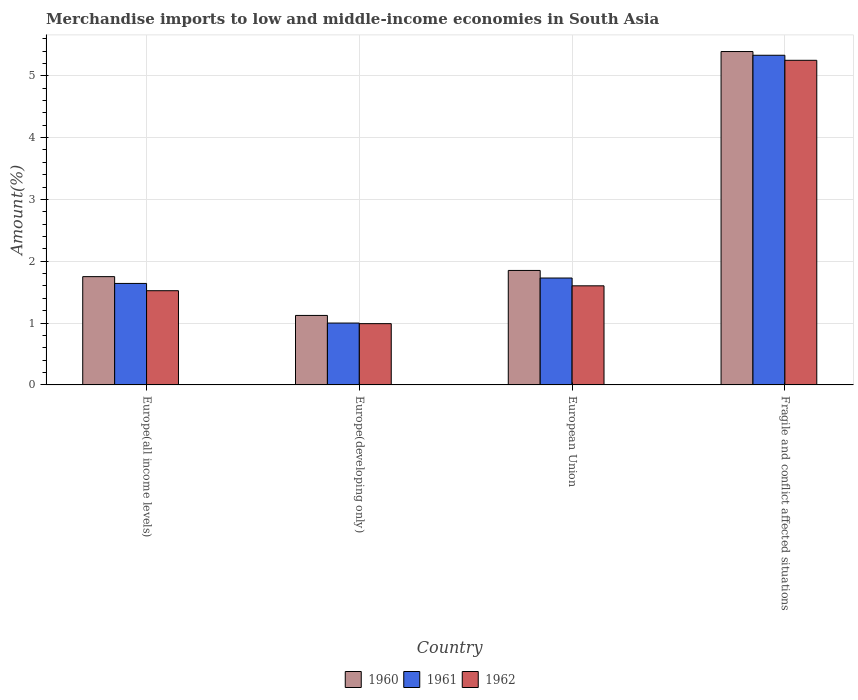How many different coloured bars are there?
Give a very brief answer. 3. How many groups of bars are there?
Provide a short and direct response. 4. Are the number of bars per tick equal to the number of legend labels?
Make the answer very short. Yes. What is the label of the 4th group of bars from the left?
Keep it short and to the point. Fragile and conflict affected situations. In how many cases, is the number of bars for a given country not equal to the number of legend labels?
Ensure brevity in your answer.  0. What is the percentage of amount earned from merchandise imports in 1962 in Fragile and conflict affected situations?
Offer a very short reply. 5.25. Across all countries, what is the maximum percentage of amount earned from merchandise imports in 1961?
Make the answer very short. 5.33. Across all countries, what is the minimum percentage of amount earned from merchandise imports in 1960?
Your answer should be very brief. 1.12. In which country was the percentage of amount earned from merchandise imports in 1960 maximum?
Offer a terse response. Fragile and conflict affected situations. In which country was the percentage of amount earned from merchandise imports in 1960 minimum?
Offer a terse response. Europe(developing only). What is the total percentage of amount earned from merchandise imports in 1962 in the graph?
Your answer should be very brief. 9.37. What is the difference between the percentage of amount earned from merchandise imports in 1961 in Europe(developing only) and that in Fragile and conflict affected situations?
Your answer should be very brief. -4.33. What is the difference between the percentage of amount earned from merchandise imports in 1962 in European Union and the percentage of amount earned from merchandise imports in 1961 in Europe(developing only)?
Your answer should be compact. 0.6. What is the average percentage of amount earned from merchandise imports in 1962 per country?
Your answer should be very brief. 2.34. What is the difference between the percentage of amount earned from merchandise imports of/in 1962 and percentage of amount earned from merchandise imports of/in 1960 in European Union?
Offer a terse response. -0.25. What is the ratio of the percentage of amount earned from merchandise imports in 1962 in Europe(all income levels) to that in Europe(developing only)?
Offer a terse response. 1.54. Is the percentage of amount earned from merchandise imports in 1961 in Europe(all income levels) less than that in European Union?
Your answer should be very brief. Yes. Is the difference between the percentage of amount earned from merchandise imports in 1962 in European Union and Fragile and conflict affected situations greater than the difference between the percentage of amount earned from merchandise imports in 1960 in European Union and Fragile and conflict affected situations?
Your answer should be compact. No. What is the difference between the highest and the second highest percentage of amount earned from merchandise imports in 1962?
Make the answer very short. -3.65. What is the difference between the highest and the lowest percentage of amount earned from merchandise imports in 1962?
Offer a terse response. 4.26. In how many countries, is the percentage of amount earned from merchandise imports in 1961 greater than the average percentage of amount earned from merchandise imports in 1961 taken over all countries?
Your response must be concise. 1. What does the 1st bar from the right in European Union represents?
Your answer should be very brief. 1962. How many bars are there?
Keep it short and to the point. 12. How many countries are there in the graph?
Ensure brevity in your answer.  4. What is the difference between two consecutive major ticks on the Y-axis?
Make the answer very short. 1. Does the graph contain any zero values?
Your answer should be compact. No. Does the graph contain grids?
Ensure brevity in your answer.  Yes. Where does the legend appear in the graph?
Keep it short and to the point. Bottom center. How many legend labels are there?
Make the answer very short. 3. How are the legend labels stacked?
Your response must be concise. Horizontal. What is the title of the graph?
Provide a short and direct response. Merchandise imports to low and middle-income economies in South Asia. What is the label or title of the Y-axis?
Keep it short and to the point. Amount(%). What is the Amount(%) of 1960 in Europe(all income levels)?
Your response must be concise. 1.75. What is the Amount(%) of 1961 in Europe(all income levels)?
Your answer should be very brief. 1.64. What is the Amount(%) of 1962 in Europe(all income levels)?
Ensure brevity in your answer.  1.52. What is the Amount(%) of 1960 in Europe(developing only)?
Provide a short and direct response. 1.12. What is the Amount(%) of 1961 in Europe(developing only)?
Offer a terse response. 1. What is the Amount(%) of 1962 in Europe(developing only)?
Your answer should be compact. 0.99. What is the Amount(%) of 1960 in European Union?
Your response must be concise. 1.85. What is the Amount(%) of 1961 in European Union?
Your answer should be compact. 1.73. What is the Amount(%) in 1962 in European Union?
Make the answer very short. 1.6. What is the Amount(%) in 1960 in Fragile and conflict affected situations?
Give a very brief answer. 5.39. What is the Amount(%) of 1961 in Fragile and conflict affected situations?
Provide a short and direct response. 5.33. What is the Amount(%) of 1962 in Fragile and conflict affected situations?
Your response must be concise. 5.25. Across all countries, what is the maximum Amount(%) in 1960?
Provide a succinct answer. 5.39. Across all countries, what is the maximum Amount(%) of 1961?
Provide a short and direct response. 5.33. Across all countries, what is the maximum Amount(%) in 1962?
Your answer should be very brief. 5.25. Across all countries, what is the minimum Amount(%) in 1960?
Your answer should be compact. 1.12. Across all countries, what is the minimum Amount(%) in 1961?
Offer a terse response. 1. Across all countries, what is the minimum Amount(%) of 1962?
Keep it short and to the point. 0.99. What is the total Amount(%) in 1960 in the graph?
Your answer should be very brief. 10.12. What is the total Amount(%) in 1961 in the graph?
Ensure brevity in your answer.  9.7. What is the total Amount(%) of 1962 in the graph?
Ensure brevity in your answer.  9.37. What is the difference between the Amount(%) of 1960 in Europe(all income levels) and that in Europe(developing only)?
Offer a very short reply. 0.63. What is the difference between the Amount(%) in 1961 in Europe(all income levels) and that in Europe(developing only)?
Provide a succinct answer. 0.64. What is the difference between the Amount(%) of 1962 in Europe(all income levels) and that in Europe(developing only)?
Make the answer very short. 0.53. What is the difference between the Amount(%) of 1960 in Europe(all income levels) and that in European Union?
Keep it short and to the point. -0.1. What is the difference between the Amount(%) of 1961 in Europe(all income levels) and that in European Union?
Ensure brevity in your answer.  -0.09. What is the difference between the Amount(%) of 1962 in Europe(all income levels) and that in European Union?
Ensure brevity in your answer.  -0.08. What is the difference between the Amount(%) in 1960 in Europe(all income levels) and that in Fragile and conflict affected situations?
Provide a short and direct response. -3.64. What is the difference between the Amount(%) of 1961 in Europe(all income levels) and that in Fragile and conflict affected situations?
Provide a short and direct response. -3.69. What is the difference between the Amount(%) of 1962 in Europe(all income levels) and that in Fragile and conflict affected situations?
Provide a succinct answer. -3.73. What is the difference between the Amount(%) of 1960 in Europe(developing only) and that in European Union?
Make the answer very short. -0.73. What is the difference between the Amount(%) in 1961 in Europe(developing only) and that in European Union?
Offer a terse response. -0.73. What is the difference between the Amount(%) in 1962 in Europe(developing only) and that in European Union?
Ensure brevity in your answer.  -0.61. What is the difference between the Amount(%) in 1960 in Europe(developing only) and that in Fragile and conflict affected situations?
Keep it short and to the point. -4.27. What is the difference between the Amount(%) of 1961 in Europe(developing only) and that in Fragile and conflict affected situations?
Give a very brief answer. -4.33. What is the difference between the Amount(%) in 1962 in Europe(developing only) and that in Fragile and conflict affected situations?
Provide a succinct answer. -4.26. What is the difference between the Amount(%) in 1960 in European Union and that in Fragile and conflict affected situations?
Make the answer very short. -3.54. What is the difference between the Amount(%) of 1961 in European Union and that in Fragile and conflict affected situations?
Your response must be concise. -3.6. What is the difference between the Amount(%) of 1962 in European Union and that in Fragile and conflict affected situations?
Offer a very short reply. -3.65. What is the difference between the Amount(%) of 1960 in Europe(all income levels) and the Amount(%) of 1961 in Europe(developing only)?
Make the answer very short. 0.75. What is the difference between the Amount(%) of 1960 in Europe(all income levels) and the Amount(%) of 1962 in Europe(developing only)?
Your response must be concise. 0.76. What is the difference between the Amount(%) of 1961 in Europe(all income levels) and the Amount(%) of 1962 in Europe(developing only)?
Make the answer very short. 0.65. What is the difference between the Amount(%) in 1960 in Europe(all income levels) and the Amount(%) in 1961 in European Union?
Your response must be concise. 0.02. What is the difference between the Amount(%) in 1960 in Europe(all income levels) and the Amount(%) in 1962 in European Union?
Offer a terse response. 0.15. What is the difference between the Amount(%) in 1961 in Europe(all income levels) and the Amount(%) in 1962 in European Union?
Your answer should be compact. 0.04. What is the difference between the Amount(%) of 1960 in Europe(all income levels) and the Amount(%) of 1961 in Fragile and conflict affected situations?
Keep it short and to the point. -3.58. What is the difference between the Amount(%) in 1960 in Europe(all income levels) and the Amount(%) in 1962 in Fragile and conflict affected situations?
Ensure brevity in your answer.  -3.5. What is the difference between the Amount(%) of 1961 in Europe(all income levels) and the Amount(%) of 1962 in Fragile and conflict affected situations?
Your answer should be compact. -3.61. What is the difference between the Amount(%) of 1960 in Europe(developing only) and the Amount(%) of 1961 in European Union?
Ensure brevity in your answer.  -0.61. What is the difference between the Amount(%) of 1960 in Europe(developing only) and the Amount(%) of 1962 in European Union?
Keep it short and to the point. -0.48. What is the difference between the Amount(%) in 1961 in Europe(developing only) and the Amount(%) in 1962 in European Union?
Ensure brevity in your answer.  -0.6. What is the difference between the Amount(%) in 1960 in Europe(developing only) and the Amount(%) in 1961 in Fragile and conflict affected situations?
Keep it short and to the point. -4.21. What is the difference between the Amount(%) in 1960 in Europe(developing only) and the Amount(%) in 1962 in Fragile and conflict affected situations?
Your response must be concise. -4.13. What is the difference between the Amount(%) in 1961 in Europe(developing only) and the Amount(%) in 1962 in Fragile and conflict affected situations?
Offer a terse response. -4.25. What is the difference between the Amount(%) of 1960 in European Union and the Amount(%) of 1961 in Fragile and conflict affected situations?
Your answer should be compact. -3.48. What is the difference between the Amount(%) of 1960 in European Union and the Amount(%) of 1962 in Fragile and conflict affected situations?
Make the answer very short. -3.4. What is the difference between the Amount(%) of 1961 in European Union and the Amount(%) of 1962 in Fragile and conflict affected situations?
Give a very brief answer. -3.52. What is the average Amount(%) of 1960 per country?
Your response must be concise. 2.53. What is the average Amount(%) of 1961 per country?
Ensure brevity in your answer.  2.43. What is the average Amount(%) of 1962 per country?
Keep it short and to the point. 2.34. What is the difference between the Amount(%) of 1960 and Amount(%) of 1961 in Europe(all income levels)?
Provide a succinct answer. 0.11. What is the difference between the Amount(%) of 1960 and Amount(%) of 1962 in Europe(all income levels)?
Your response must be concise. 0.23. What is the difference between the Amount(%) of 1961 and Amount(%) of 1962 in Europe(all income levels)?
Offer a terse response. 0.12. What is the difference between the Amount(%) of 1960 and Amount(%) of 1961 in Europe(developing only)?
Your answer should be very brief. 0.12. What is the difference between the Amount(%) in 1960 and Amount(%) in 1962 in Europe(developing only)?
Your answer should be very brief. 0.13. What is the difference between the Amount(%) of 1961 and Amount(%) of 1962 in Europe(developing only)?
Your answer should be compact. 0.01. What is the difference between the Amount(%) in 1960 and Amount(%) in 1961 in European Union?
Your response must be concise. 0.12. What is the difference between the Amount(%) in 1960 and Amount(%) in 1962 in European Union?
Your answer should be very brief. 0.25. What is the difference between the Amount(%) in 1961 and Amount(%) in 1962 in European Union?
Provide a short and direct response. 0.13. What is the difference between the Amount(%) in 1960 and Amount(%) in 1961 in Fragile and conflict affected situations?
Ensure brevity in your answer.  0.06. What is the difference between the Amount(%) in 1960 and Amount(%) in 1962 in Fragile and conflict affected situations?
Provide a succinct answer. 0.14. What is the difference between the Amount(%) in 1961 and Amount(%) in 1962 in Fragile and conflict affected situations?
Offer a very short reply. 0.08. What is the ratio of the Amount(%) of 1960 in Europe(all income levels) to that in Europe(developing only)?
Offer a terse response. 1.56. What is the ratio of the Amount(%) in 1961 in Europe(all income levels) to that in Europe(developing only)?
Give a very brief answer. 1.64. What is the ratio of the Amount(%) of 1962 in Europe(all income levels) to that in Europe(developing only)?
Offer a terse response. 1.54. What is the ratio of the Amount(%) of 1960 in Europe(all income levels) to that in European Union?
Offer a terse response. 0.95. What is the ratio of the Amount(%) of 1961 in Europe(all income levels) to that in European Union?
Offer a terse response. 0.95. What is the ratio of the Amount(%) of 1962 in Europe(all income levels) to that in European Union?
Ensure brevity in your answer.  0.95. What is the ratio of the Amount(%) in 1960 in Europe(all income levels) to that in Fragile and conflict affected situations?
Make the answer very short. 0.32. What is the ratio of the Amount(%) in 1961 in Europe(all income levels) to that in Fragile and conflict affected situations?
Provide a succinct answer. 0.31. What is the ratio of the Amount(%) of 1962 in Europe(all income levels) to that in Fragile and conflict affected situations?
Ensure brevity in your answer.  0.29. What is the ratio of the Amount(%) in 1960 in Europe(developing only) to that in European Union?
Offer a very short reply. 0.61. What is the ratio of the Amount(%) of 1961 in Europe(developing only) to that in European Union?
Offer a very short reply. 0.58. What is the ratio of the Amount(%) of 1962 in Europe(developing only) to that in European Union?
Offer a terse response. 0.62. What is the ratio of the Amount(%) in 1960 in Europe(developing only) to that in Fragile and conflict affected situations?
Keep it short and to the point. 0.21. What is the ratio of the Amount(%) of 1961 in Europe(developing only) to that in Fragile and conflict affected situations?
Give a very brief answer. 0.19. What is the ratio of the Amount(%) of 1962 in Europe(developing only) to that in Fragile and conflict affected situations?
Offer a terse response. 0.19. What is the ratio of the Amount(%) in 1960 in European Union to that in Fragile and conflict affected situations?
Keep it short and to the point. 0.34. What is the ratio of the Amount(%) of 1961 in European Union to that in Fragile and conflict affected situations?
Your response must be concise. 0.32. What is the ratio of the Amount(%) in 1962 in European Union to that in Fragile and conflict affected situations?
Your answer should be compact. 0.31. What is the difference between the highest and the second highest Amount(%) of 1960?
Your response must be concise. 3.54. What is the difference between the highest and the second highest Amount(%) of 1961?
Give a very brief answer. 3.6. What is the difference between the highest and the second highest Amount(%) of 1962?
Your answer should be compact. 3.65. What is the difference between the highest and the lowest Amount(%) in 1960?
Give a very brief answer. 4.27. What is the difference between the highest and the lowest Amount(%) of 1961?
Provide a succinct answer. 4.33. What is the difference between the highest and the lowest Amount(%) in 1962?
Your answer should be compact. 4.26. 